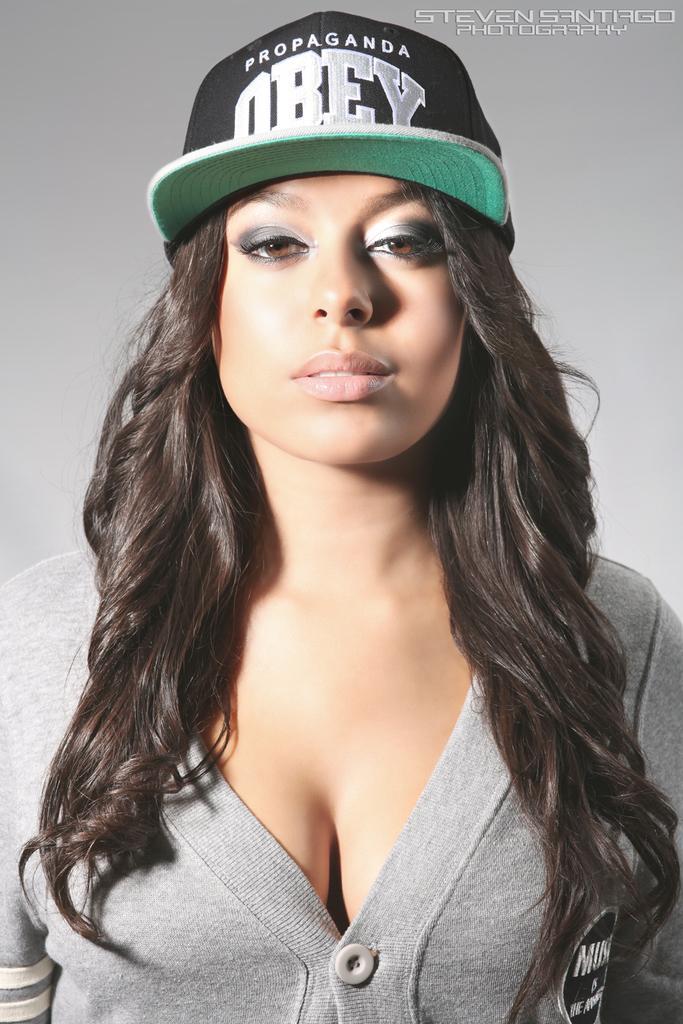How would you summarize this image in a sentence or two? In this image I can see the person and the person is wearing light gray color shirt and black and green color cap and I can see the white and gray color background. 